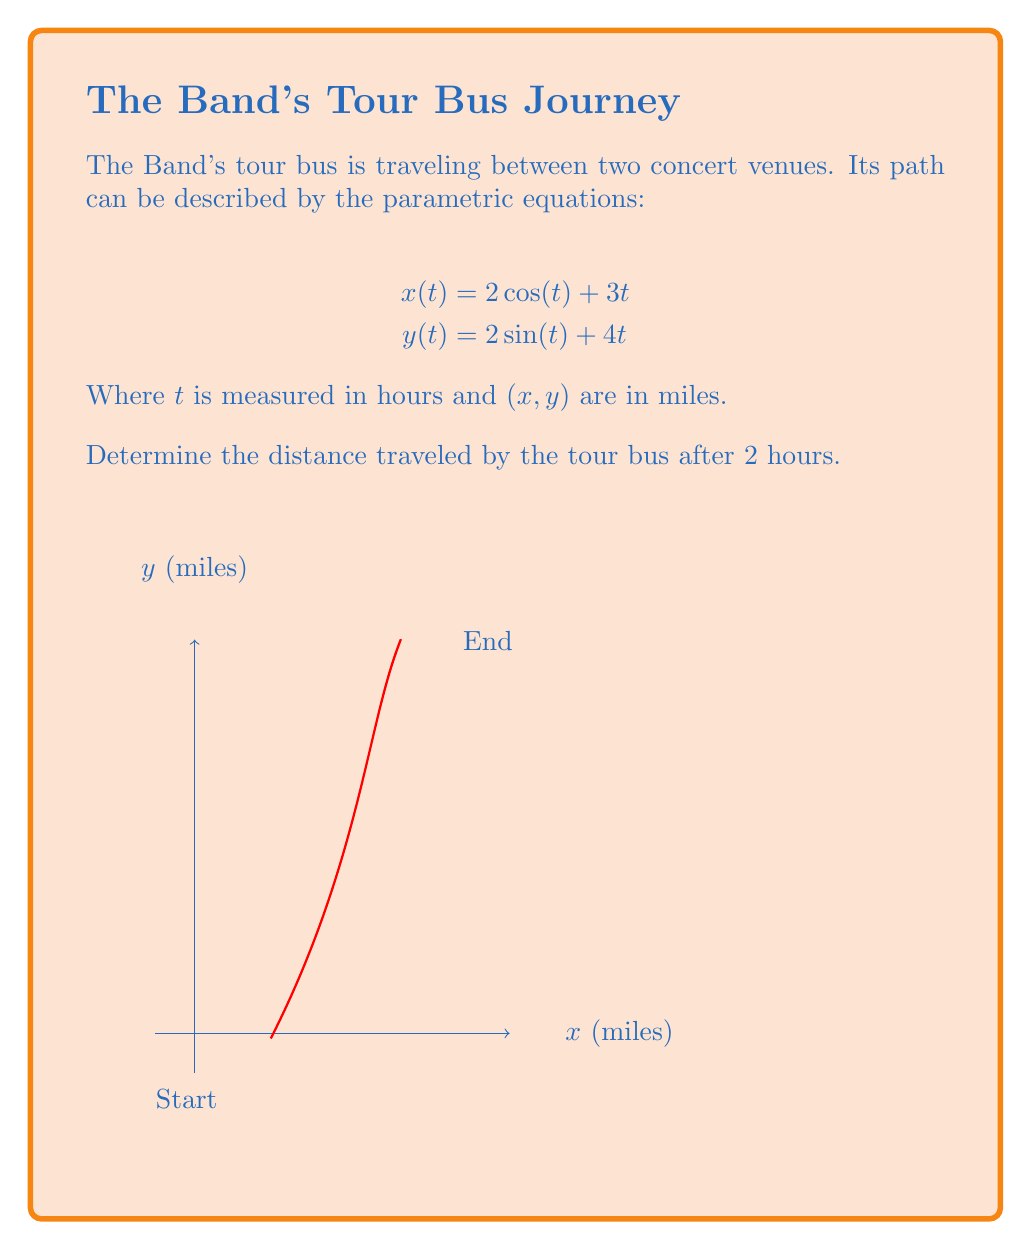Could you help me with this problem? To find the distance traveled, we need to calculate the arc length of the parametric curve over the given time interval. The formula for arc length is:

$$L = \int_a^b \sqrt{\left(\frac{dx}{dt}\right)^2 + \left(\frac{dy}{dt}\right)^2} dt$$

Step 1: Find $\frac{dx}{dt}$ and $\frac{dy}{dt}$
$$\frac{dx}{dt} = -2\sin(t) + 3$$
$$\frac{dy}{dt} = 2\cos(t) + 4$$

Step 2: Substitute into the arc length formula
$$L = \int_0^2 \sqrt{(-2\sin(t) + 3)^2 + (2\cos(t) + 4)^2} dt$$

Step 3: Simplify the expression under the square root
$$\begin{align*}
(-2\sin(t) + 3)^2 + (2\cos(t) + 4)^2 &= 4\sin^2(t) - 12\sin(t) + 9 + 4\cos^2(t) + 16\cos(t) + 16 \\
&= 4(\sin^2(t) + \cos^2(t)) - 12\sin(t) + 16\cos(t) + 25 \\
&= 4 - 12\sin(t) + 16\cos(t) + 25 \\
&= 29 - 12\sin(t) + 16\cos(t)
\end{align*}$$

Step 4: The integral becomes
$$L = \int_0^2 \sqrt{29 - 12\sin(t) + 16\cos(t)} dt$$

This integral cannot be evaluated analytically, so we need to use numerical methods to approximate it.

Step 5: Use a numerical integration method (e.g., Simpson's rule or a computer algebra system) to evaluate the integral.

The result of this numerical integration is approximately 10.77 miles.
Answer: 10.77 miles 